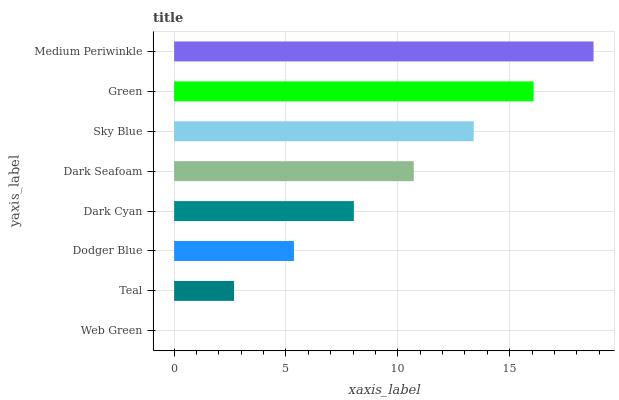Is Web Green the minimum?
Answer yes or no. Yes. Is Medium Periwinkle the maximum?
Answer yes or no. Yes. Is Teal the minimum?
Answer yes or no. No. Is Teal the maximum?
Answer yes or no. No. Is Teal greater than Web Green?
Answer yes or no. Yes. Is Web Green less than Teal?
Answer yes or no. Yes. Is Web Green greater than Teal?
Answer yes or no. No. Is Teal less than Web Green?
Answer yes or no. No. Is Dark Seafoam the high median?
Answer yes or no. Yes. Is Dark Cyan the low median?
Answer yes or no. Yes. Is Sky Blue the high median?
Answer yes or no. No. Is Dodger Blue the low median?
Answer yes or no. No. 